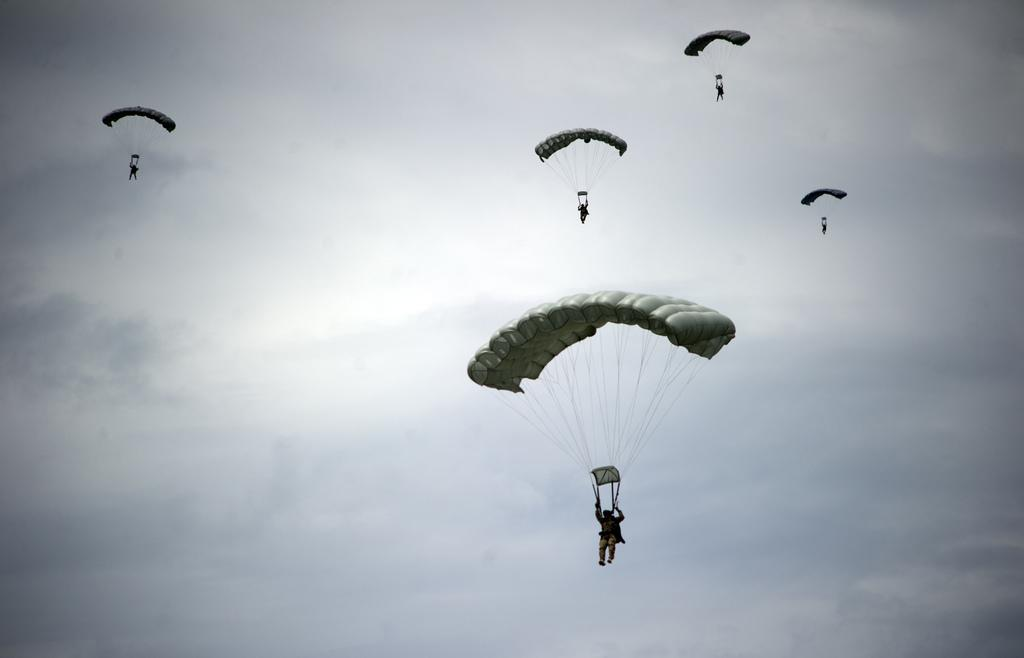How many people are in the image? There are five individuals in the image. What are the individuals doing in the image? The individuals are flying with parachutes. What can be seen in the background of the image? The sky is visible in the background of the image. What type of weather is suggested by the presence of clouds in the sky? The presence of clouds in the sky suggests that the weather might be partly cloudy or overcast. What type of screw is being used to hold the parachute together in the image? There is no screw present in the image; the parachutes are held together by fabric and straps. What type of feast is being prepared by the individuals in the image? There is no feast being prepared in the image; the individuals are flying with parachutes. 